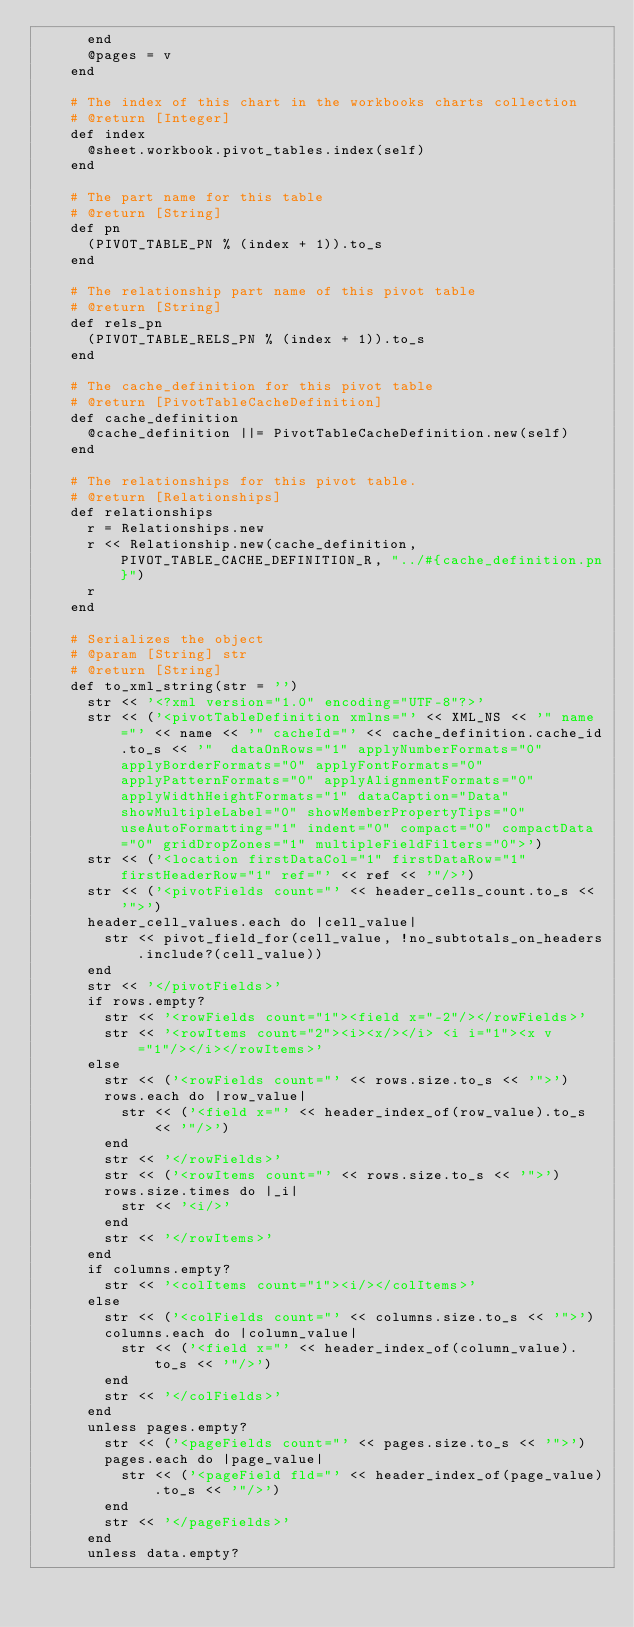Convert code to text. <code><loc_0><loc_0><loc_500><loc_500><_Ruby_>      end
      @pages = v
    end

    # The index of this chart in the workbooks charts collection
    # @return [Integer]
    def index
      @sheet.workbook.pivot_tables.index(self)
    end

    # The part name for this table
    # @return [String]
    def pn
      (PIVOT_TABLE_PN % (index + 1)).to_s
    end

    # The relationship part name of this pivot table
    # @return [String]
    def rels_pn
      (PIVOT_TABLE_RELS_PN % (index + 1)).to_s
    end

    # The cache_definition for this pivot table
    # @return [PivotTableCacheDefinition]
    def cache_definition
      @cache_definition ||= PivotTableCacheDefinition.new(self)
    end

    # The relationships for this pivot table.
    # @return [Relationships]
    def relationships
      r = Relationships.new
      r << Relationship.new(cache_definition, PIVOT_TABLE_CACHE_DEFINITION_R, "../#{cache_definition.pn}")
      r
    end

    # Serializes the object
    # @param [String] str
    # @return [String]
    def to_xml_string(str = '')
      str << '<?xml version="1.0" encoding="UTF-8"?>'
      str << ('<pivotTableDefinition xmlns="' << XML_NS << '" name="' << name << '" cacheId="' << cache_definition.cache_id.to_s << '"  dataOnRows="1" applyNumberFormats="0" applyBorderFormats="0" applyFontFormats="0" applyPatternFormats="0" applyAlignmentFormats="0" applyWidthHeightFormats="1" dataCaption="Data" showMultipleLabel="0" showMemberPropertyTips="0" useAutoFormatting="1" indent="0" compact="0" compactData="0" gridDropZones="1" multipleFieldFilters="0">')
      str << ('<location firstDataCol="1" firstDataRow="1" firstHeaderRow="1" ref="' << ref << '"/>')
      str << ('<pivotFields count="' << header_cells_count.to_s << '">')
      header_cell_values.each do |cell_value|
        str << pivot_field_for(cell_value, !no_subtotals_on_headers.include?(cell_value))
      end
      str << '</pivotFields>'
      if rows.empty?
        str << '<rowFields count="1"><field x="-2"/></rowFields>'
        str << '<rowItems count="2"><i><x/></i> <i i="1"><x v="1"/></i></rowItems>'
      else
        str << ('<rowFields count="' << rows.size.to_s << '">')
        rows.each do |row_value|
          str << ('<field x="' << header_index_of(row_value).to_s << '"/>')
        end
        str << '</rowFields>'
        str << ('<rowItems count="' << rows.size.to_s << '">')
        rows.size.times do |_i|
          str << '<i/>'
        end
        str << '</rowItems>'
      end
      if columns.empty?
        str << '<colItems count="1"><i/></colItems>'
      else
        str << ('<colFields count="' << columns.size.to_s << '">')
        columns.each do |column_value|
          str << ('<field x="' << header_index_of(column_value).to_s << '"/>')
        end
        str << '</colFields>'
      end
      unless pages.empty?
        str << ('<pageFields count="' << pages.size.to_s << '">')
        pages.each do |page_value|
          str << ('<pageField fld="' << header_index_of(page_value).to_s << '"/>')
        end
        str << '</pageFields>'
      end
      unless data.empty?</code> 